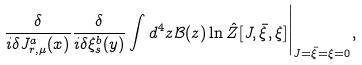Convert formula to latex. <formula><loc_0><loc_0><loc_500><loc_500>\frac { \delta } { i \delta J _ { r , \mu } ^ { a } ( x ) } \frac { \delta } { i \delta \xi _ { s } ^ { b } ( y ) } \int d ^ { 4 } z \mathcal { B } ( z ) \ln \hat { Z } [ J , \bar { \xi } , \xi ] \Big | _ { J = \bar { \xi } = \xi = 0 } ,</formula> 